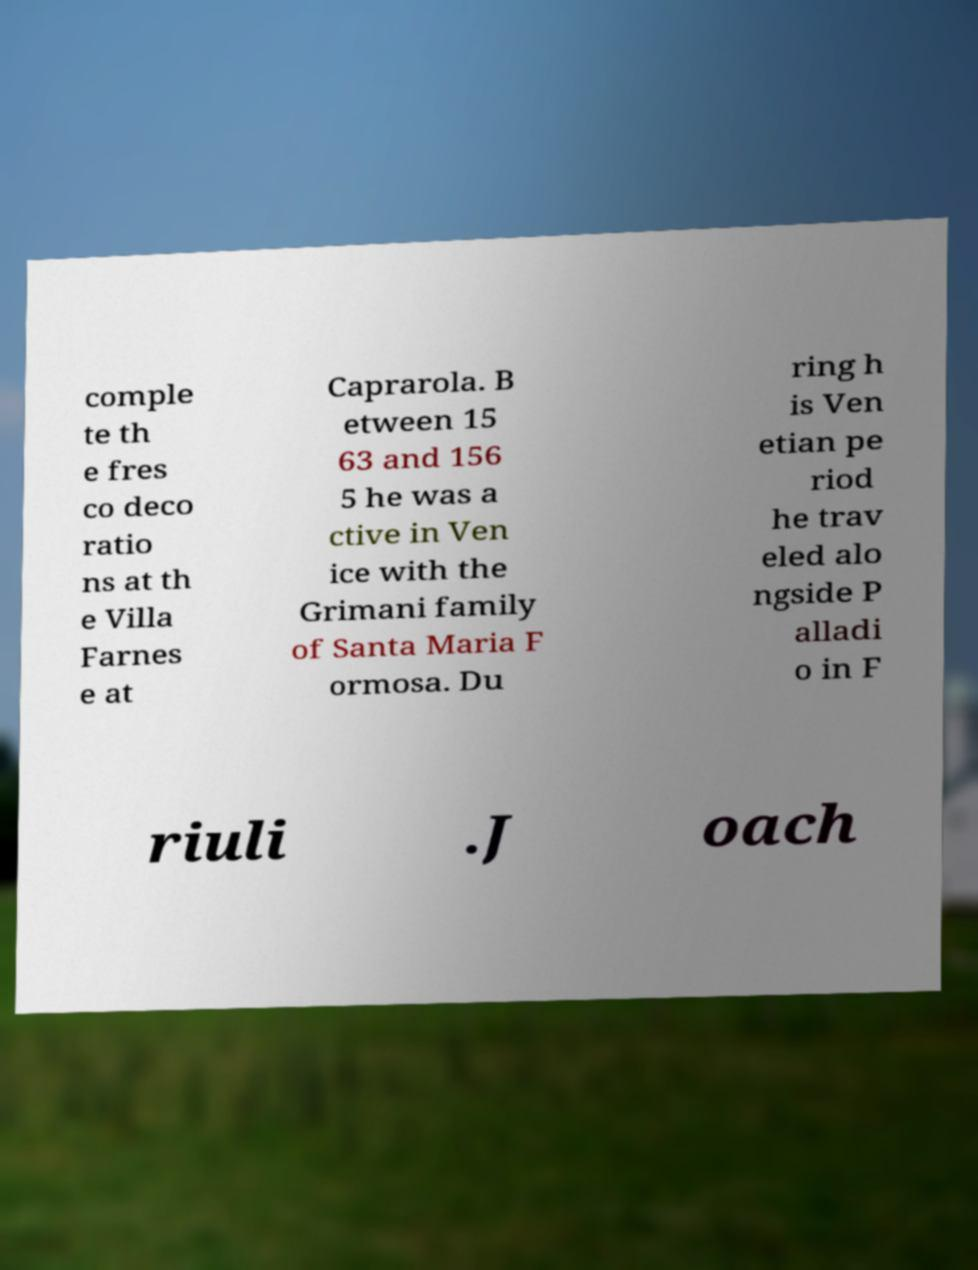For documentation purposes, I need the text within this image transcribed. Could you provide that? comple te th e fres co deco ratio ns at th e Villa Farnes e at Caprarola. B etween 15 63 and 156 5 he was a ctive in Ven ice with the Grimani family of Santa Maria F ormosa. Du ring h is Ven etian pe riod he trav eled alo ngside P alladi o in F riuli .J oach 